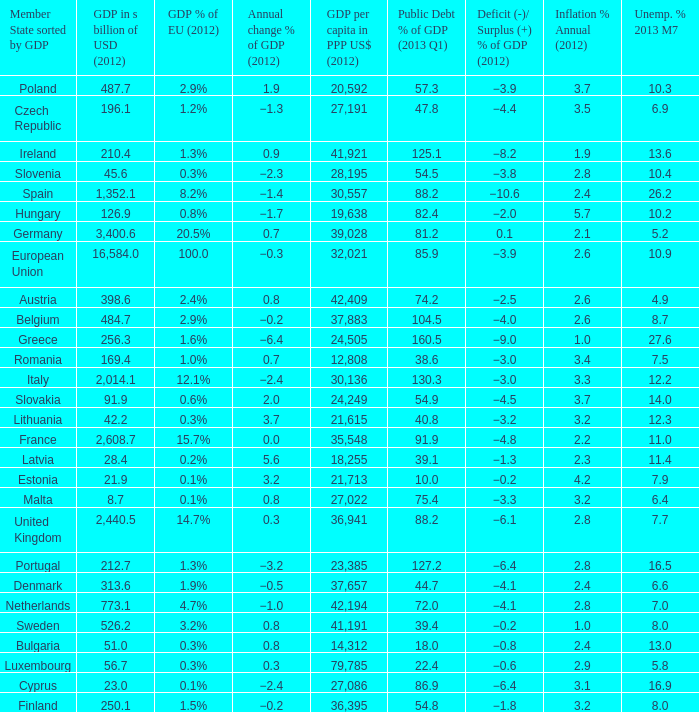What is the average public debt % of GDP in 2013 Q1 of the country with a member slate sorted by GDP of Czech Republic and a GDP per capita in PPP US dollars in 2012 greater than 27,191? None. 